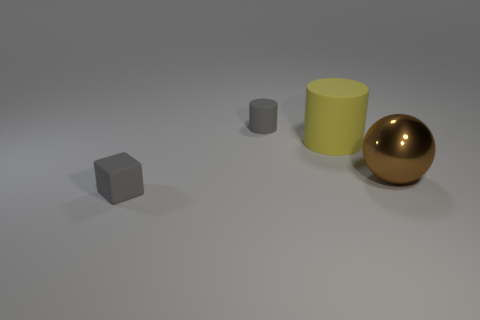Can you describe the lighting condition in the image? The lighting in the image seems to come from above, casting soft shadows directly underneath the objects, suggesting a diffused light source. 